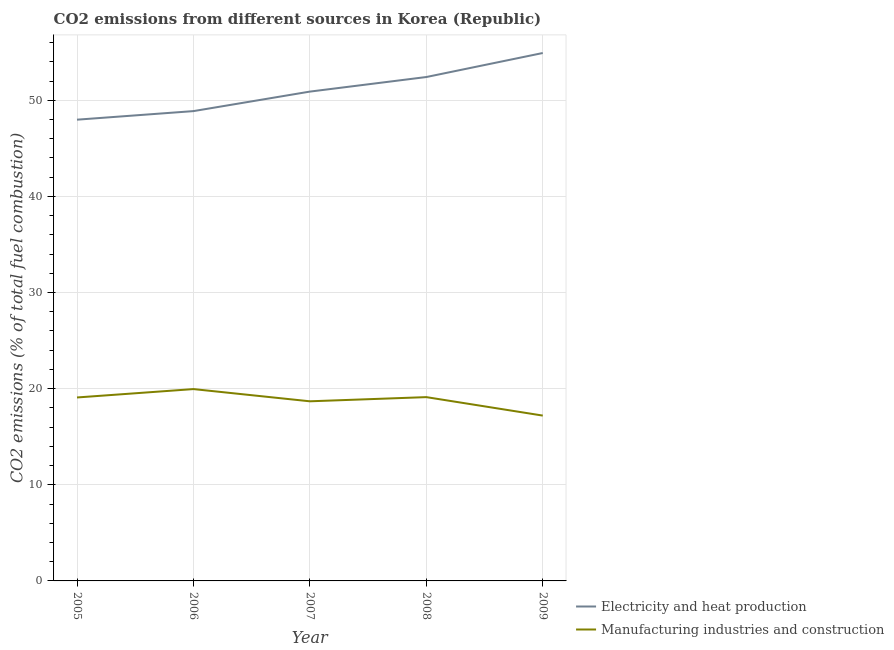Does the line corresponding to co2 emissions due to manufacturing industries intersect with the line corresponding to co2 emissions due to electricity and heat production?
Offer a terse response. No. What is the co2 emissions due to manufacturing industries in 2005?
Provide a succinct answer. 19.08. Across all years, what is the maximum co2 emissions due to manufacturing industries?
Give a very brief answer. 19.95. Across all years, what is the minimum co2 emissions due to manufacturing industries?
Offer a terse response. 17.2. What is the total co2 emissions due to manufacturing industries in the graph?
Your answer should be compact. 94.04. What is the difference between the co2 emissions due to manufacturing industries in 2007 and that in 2008?
Provide a succinct answer. -0.43. What is the difference between the co2 emissions due to manufacturing industries in 2006 and the co2 emissions due to electricity and heat production in 2005?
Ensure brevity in your answer.  -28.02. What is the average co2 emissions due to electricity and heat production per year?
Offer a terse response. 51.01. In the year 2005, what is the difference between the co2 emissions due to manufacturing industries and co2 emissions due to electricity and heat production?
Offer a terse response. -28.89. What is the ratio of the co2 emissions due to electricity and heat production in 2005 to that in 2007?
Your answer should be very brief. 0.94. What is the difference between the highest and the second highest co2 emissions due to electricity and heat production?
Ensure brevity in your answer.  2.5. What is the difference between the highest and the lowest co2 emissions due to electricity and heat production?
Give a very brief answer. 6.94. Is the co2 emissions due to electricity and heat production strictly less than the co2 emissions due to manufacturing industries over the years?
Ensure brevity in your answer.  No. How many years are there in the graph?
Give a very brief answer. 5. What is the difference between two consecutive major ticks on the Y-axis?
Your response must be concise. 10. Does the graph contain grids?
Offer a very short reply. Yes. How are the legend labels stacked?
Provide a short and direct response. Vertical. What is the title of the graph?
Your response must be concise. CO2 emissions from different sources in Korea (Republic). What is the label or title of the Y-axis?
Give a very brief answer. CO2 emissions (% of total fuel combustion). What is the CO2 emissions (% of total fuel combustion) of Electricity and heat production in 2005?
Your answer should be very brief. 47.98. What is the CO2 emissions (% of total fuel combustion) of Manufacturing industries and construction in 2005?
Provide a short and direct response. 19.08. What is the CO2 emissions (% of total fuel combustion) of Electricity and heat production in 2006?
Give a very brief answer. 48.87. What is the CO2 emissions (% of total fuel combustion) of Manufacturing industries and construction in 2006?
Offer a very short reply. 19.95. What is the CO2 emissions (% of total fuel combustion) in Electricity and heat production in 2007?
Provide a short and direct response. 50.9. What is the CO2 emissions (% of total fuel combustion) of Manufacturing industries and construction in 2007?
Your answer should be very brief. 18.68. What is the CO2 emissions (% of total fuel combustion) of Electricity and heat production in 2008?
Provide a succinct answer. 52.41. What is the CO2 emissions (% of total fuel combustion) in Manufacturing industries and construction in 2008?
Keep it short and to the point. 19.12. What is the CO2 emissions (% of total fuel combustion) in Electricity and heat production in 2009?
Provide a succinct answer. 54.91. What is the CO2 emissions (% of total fuel combustion) in Manufacturing industries and construction in 2009?
Your answer should be compact. 17.2. Across all years, what is the maximum CO2 emissions (% of total fuel combustion) of Electricity and heat production?
Give a very brief answer. 54.91. Across all years, what is the maximum CO2 emissions (% of total fuel combustion) of Manufacturing industries and construction?
Offer a terse response. 19.95. Across all years, what is the minimum CO2 emissions (% of total fuel combustion) of Electricity and heat production?
Your answer should be compact. 47.98. Across all years, what is the minimum CO2 emissions (% of total fuel combustion) in Manufacturing industries and construction?
Offer a very short reply. 17.2. What is the total CO2 emissions (% of total fuel combustion) of Electricity and heat production in the graph?
Your answer should be compact. 255.07. What is the total CO2 emissions (% of total fuel combustion) in Manufacturing industries and construction in the graph?
Give a very brief answer. 94.04. What is the difference between the CO2 emissions (% of total fuel combustion) of Electricity and heat production in 2005 and that in 2006?
Your answer should be very brief. -0.89. What is the difference between the CO2 emissions (% of total fuel combustion) of Manufacturing industries and construction in 2005 and that in 2006?
Offer a terse response. -0.87. What is the difference between the CO2 emissions (% of total fuel combustion) of Electricity and heat production in 2005 and that in 2007?
Offer a very short reply. -2.92. What is the difference between the CO2 emissions (% of total fuel combustion) in Manufacturing industries and construction in 2005 and that in 2007?
Your answer should be compact. 0.4. What is the difference between the CO2 emissions (% of total fuel combustion) of Electricity and heat production in 2005 and that in 2008?
Keep it short and to the point. -4.44. What is the difference between the CO2 emissions (% of total fuel combustion) of Manufacturing industries and construction in 2005 and that in 2008?
Your answer should be compact. -0.04. What is the difference between the CO2 emissions (% of total fuel combustion) of Electricity and heat production in 2005 and that in 2009?
Your answer should be compact. -6.94. What is the difference between the CO2 emissions (% of total fuel combustion) in Manufacturing industries and construction in 2005 and that in 2009?
Your answer should be compact. 1.89. What is the difference between the CO2 emissions (% of total fuel combustion) in Electricity and heat production in 2006 and that in 2007?
Offer a very short reply. -2.03. What is the difference between the CO2 emissions (% of total fuel combustion) of Manufacturing industries and construction in 2006 and that in 2007?
Offer a terse response. 1.27. What is the difference between the CO2 emissions (% of total fuel combustion) of Electricity and heat production in 2006 and that in 2008?
Your answer should be very brief. -3.55. What is the difference between the CO2 emissions (% of total fuel combustion) in Manufacturing industries and construction in 2006 and that in 2008?
Make the answer very short. 0.84. What is the difference between the CO2 emissions (% of total fuel combustion) in Electricity and heat production in 2006 and that in 2009?
Your response must be concise. -6.04. What is the difference between the CO2 emissions (% of total fuel combustion) in Manufacturing industries and construction in 2006 and that in 2009?
Your answer should be very brief. 2.76. What is the difference between the CO2 emissions (% of total fuel combustion) in Electricity and heat production in 2007 and that in 2008?
Offer a terse response. -1.52. What is the difference between the CO2 emissions (% of total fuel combustion) of Manufacturing industries and construction in 2007 and that in 2008?
Provide a succinct answer. -0.43. What is the difference between the CO2 emissions (% of total fuel combustion) in Electricity and heat production in 2007 and that in 2009?
Offer a very short reply. -4.01. What is the difference between the CO2 emissions (% of total fuel combustion) of Manufacturing industries and construction in 2007 and that in 2009?
Your response must be concise. 1.49. What is the difference between the CO2 emissions (% of total fuel combustion) of Electricity and heat production in 2008 and that in 2009?
Provide a succinct answer. -2.5. What is the difference between the CO2 emissions (% of total fuel combustion) in Manufacturing industries and construction in 2008 and that in 2009?
Your answer should be very brief. 1.92. What is the difference between the CO2 emissions (% of total fuel combustion) of Electricity and heat production in 2005 and the CO2 emissions (% of total fuel combustion) of Manufacturing industries and construction in 2006?
Your answer should be compact. 28.02. What is the difference between the CO2 emissions (% of total fuel combustion) in Electricity and heat production in 2005 and the CO2 emissions (% of total fuel combustion) in Manufacturing industries and construction in 2007?
Provide a succinct answer. 29.29. What is the difference between the CO2 emissions (% of total fuel combustion) of Electricity and heat production in 2005 and the CO2 emissions (% of total fuel combustion) of Manufacturing industries and construction in 2008?
Your answer should be compact. 28.86. What is the difference between the CO2 emissions (% of total fuel combustion) in Electricity and heat production in 2005 and the CO2 emissions (% of total fuel combustion) in Manufacturing industries and construction in 2009?
Offer a terse response. 30.78. What is the difference between the CO2 emissions (% of total fuel combustion) in Electricity and heat production in 2006 and the CO2 emissions (% of total fuel combustion) in Manufacturing industries and construction in 2007?
Provide a succinct answer. 30.18. What is the difference between the CO2 emissions (% of total fuel combustion) of Electricity and heat production in 2006 and the CO2 emissions (% of total fuel combustion) of Manufacturing industries and construction in 2008?
Offer a very short reply. 29.75. What is the difference between the CO2 emissions (% of total fuel combustion) in Electricity and heat production in 2006 and the CO2 emissions (% of total fuel combustion) in Manufacturing industries and construction in 2009?
Offer a very short reply. 31.67. What is the difference between the CO2 emissions (% of total fuel combustion) of Electricity and heat production in 2007 and the CO2 emissions (% of total fuel combustion) of Manufacturing industries and construction in 2008?
Provide a short and direct response. 31.78. What is the difference between the CO2 emissions (% of total fuel combustion) in Electricity and heat production in 2007 and the CO2 emissions (% of total fuel combustion) in Manufacturing industries and construction in 2009?
Provide a succinct answer. 33.7. What is the difference between the CO2 emissions (% of total fuel combustion) of Electricity and heat production in 2008 and the CO2 emissions (% of total fuel combustion) of Manufacturing industries and construction in 2009?
Offer a terse response. 35.22. What is the average CO2 emissions (% of total fuel combustion) of Electricity and heat production per year?
Offer a terse response. 51.01. What is the average CO2 emissions (% of total fuel combustion) of Manufacturing industries and construction per year?
Provide a succinct answer. 18.81. In the year 2005, what is the difference between the CO2 emissions (% of total fuel combustion) of Electricity and heat production and CO2 emissions (% of total fuel combustion) of Manufacturing industries and construction?
Provide a succinct answer. 28.89. In the year 2006, what is the difference between the CO2 emissions (% of total fuel combustion) in Electricity and heat production and CO2 emissions (% of total fuel combustion) in Manufacturing industries and construction?
Ensure brevity in your answer.  28.91. In the year 2007, what is the difference between the CO2 emissions (% of total fuel combustion) in Electricity and heat production and CO2 emissions (% of total fuel combustion) in Manufacturing industries and construction?
Your answer should be compact. 32.21. In the year 2008, what is the difference between the CO2 emissions (% of total fuel combustion) in Electricity and heat production and CO2 emissions (% of total fuel combustion) in Manufacturing industries and construction?
Ensure brevity in your answer.  33.3. In the year 2009, what is the difference between the CO2 emissions (% of total fuel combustion) in Electricity and heat production and CO2 emissions (% of total fuel combustion) in Manufacturing industries and construction?
Provide a short and direct response. 37.72. What is the ratio of the CO2 emissions (% of total fuel combustion) in Electricity and heat production in 2005 to that in 2006?
Your answer should be very brief. 0.98. What is the ratio of the CO2 emissions (% of total fuel combustion) in Manufacturing industries and construction in 2005 to that in 2006?
Offer a very short reply. 0.96. What is the ratio of the CO2 emissions (% of total fuel combustion) of Electricity and heat production in 2005 to that in 2007?
Give a very brief answer. 0.94. What is the ratio of the CO2 emissions (% of total fuel combustion) in Manufacturing industries and construction in 2005 to that in 2007?
Make the answer very short. 1.02. What is the ratio of the CO2 emissions (% of total fuel combustion) of Electricity and heat production in 2005 to that in 2008?
Offer a terse response. 0.92. What is the ratio of the CO2 emissions (% of total fuel combustion) in Manufacturing industries and construction in 2005 to that in 2008?
Make the answer very short. 1. What is the ratio of the CO2 emissions (% of total fuel combustion) of Electricity and heat production in 2005 to that in 2009?
Give a very brief answer. 0.87. What is the ratio of the CO2 emissions (% of total fuel combustion) in Manufacturing industries and construction in 2005 to that in 2009?
Give a very brief answer. 1.11. What is the ratio of the CO2 emissions (% of total fuel combustion) in Electricity and heat production in 2006 to that in 2007?
Ensure brevity in your answer.  0.96. What is the ratio of the CO2 emissions (% of total fuel combustion) in Manufacturing industries and construction in 2006 to that in 2007?
Offer a very short reply. 1.07. What is the ratio of the CO2 emissions (% of total fuel combustion) in Electricity and heat production in 2006 to that in 2008?
Your answer should be compact. 0.93. What is the ratio of the CO2 emissions (% of total fuel combustion) in Manufacturing industries and construction in 2006 to that in 2008?
Provide a succinct answer. 1.04. What is the ratio of the CO2 emissions (% of total fuel combustion) of Electricity and heat production in 2006 to that in 2009?
Your answer should be compact. 0.89. What is the ratio of the CO2 emissions (% of total fuel combustion) in Manufacturing industries and construction in 2006 to that in 2009?
Provide a succinct answer. 1.16. What is the ratio of the CO2 emissions (% of total fuel combustion) of Electricity and heat production in 2007 to that in 2008?
Offer a terse response. 0.97. What is the ratio of the CO2 emissions (% of total fuel combustion) in Manufacturing industries and construction in 2007 to that in 2008?
Offer a terse response. 0.98. What is the ratio of the CO2 emissions (% of total fuel combustion) of Electricity and heat production in 2007 to that in 2009?
Ensure brevity in your answer.  0.93. What is the ratio of the CO2 emissions (% of total fuel combustion) in Manufacturing industries and construction in 2007 to that in 2009?
Your answer should be very brief. 1.09. What is the ratio of the CO2 emissions (% of total fuel combustion) in Electricity and heat production in 2008 to that in 2009?
Make the answer very short. 0.95. What is the ratio of the CO2 emissions (% of total fuel combustion) of Manufacturing industries and construction in 2008 to that in 2009?
Your response must be concise. 1.11. What is the difference between the highest and the second highest CO2 emissions (% of total fuel combustion) of Electricity and heat production?
Offer a very short reply. 2.5. What is the difference between the highest and the second highest CO2 emissions (% of total fuel combustion) in Manufacturing industries and construction?
Provide a short and direct response. 0.84. What is the difference between the highest and the lowest CO2 emissions (% of total fuel combustion) of Electricity and heat production?
Your answer should be very brief. 6.94. What is the difference between the highest and the lowest CO2 emissions (% of total fuel combustion) of Manufacturing industries and construction?
Your answer should be compact. 2.76. 